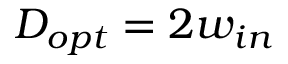<formula> <loc_0><loc_0><loc_500><loc_500>D _ { o p t } = 2 w _ { i n }</formula> 